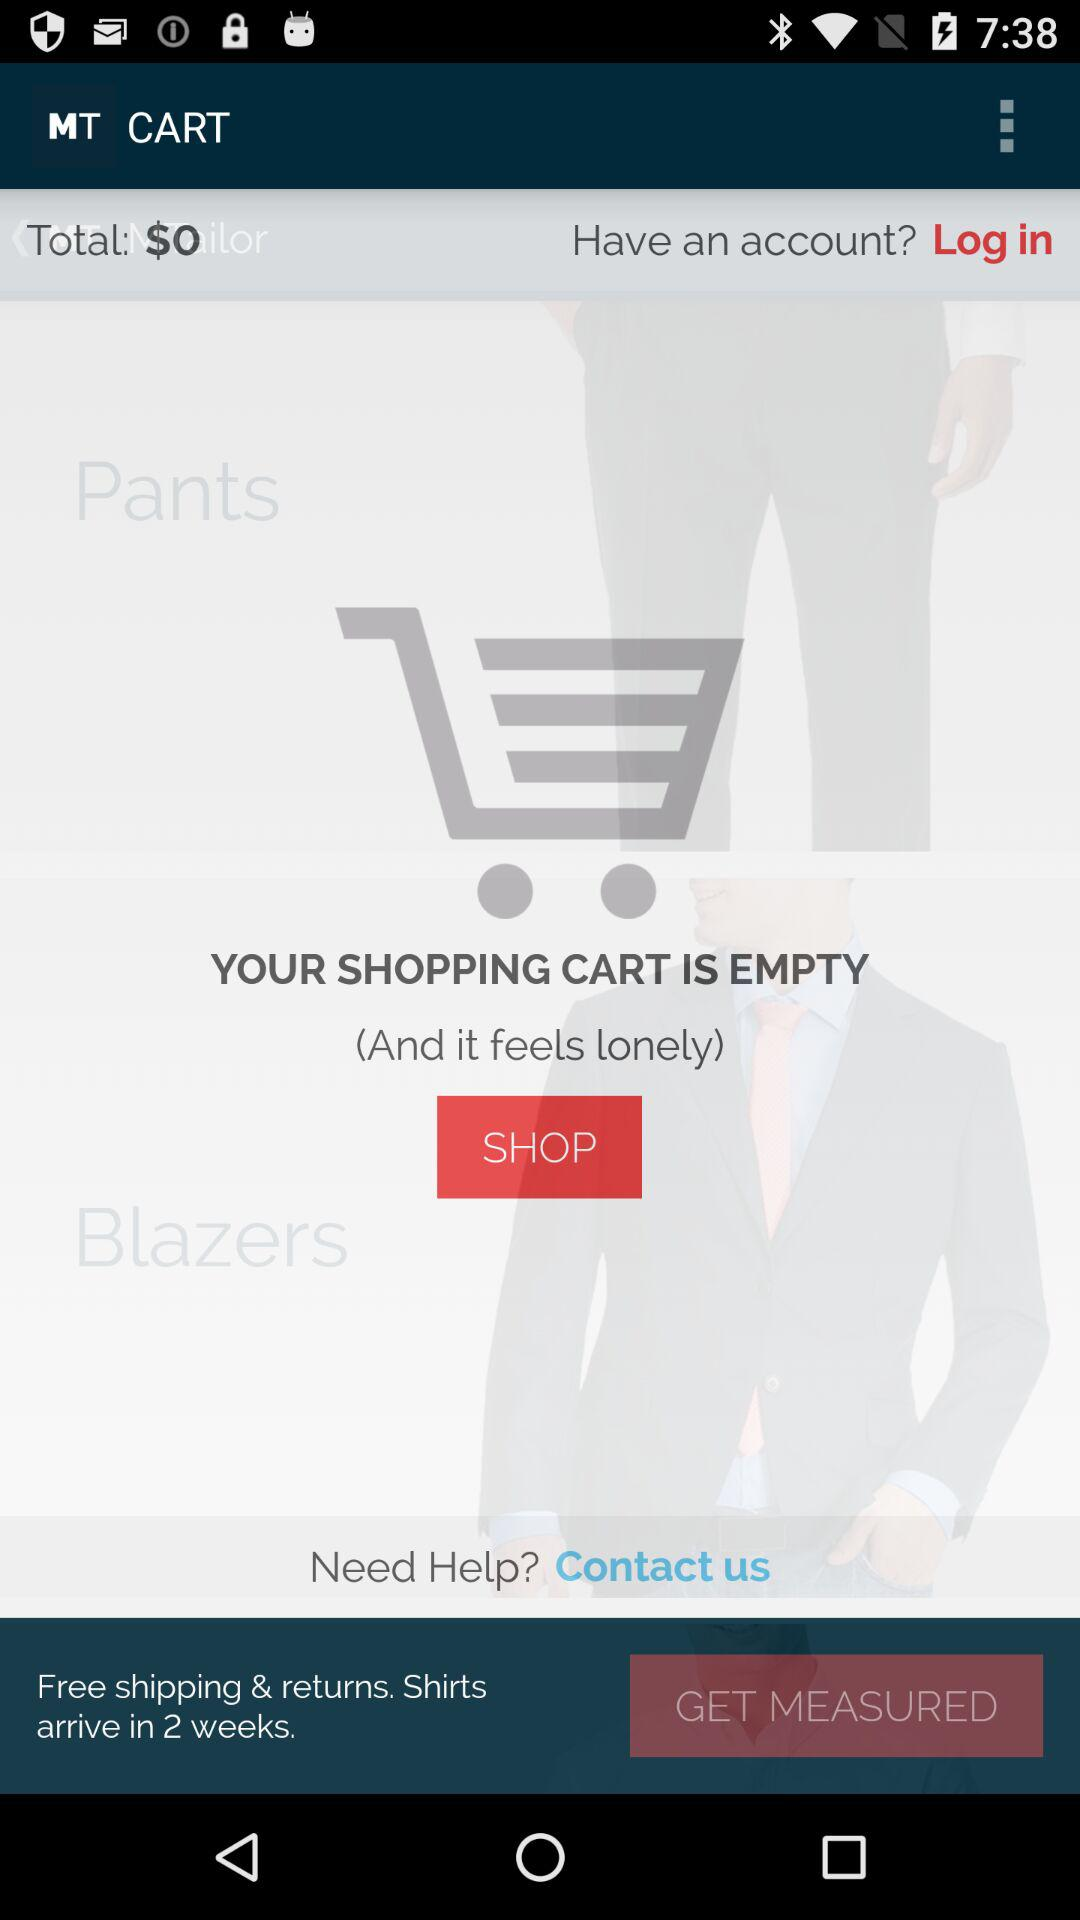What is the total amount? The total amount is $0. 